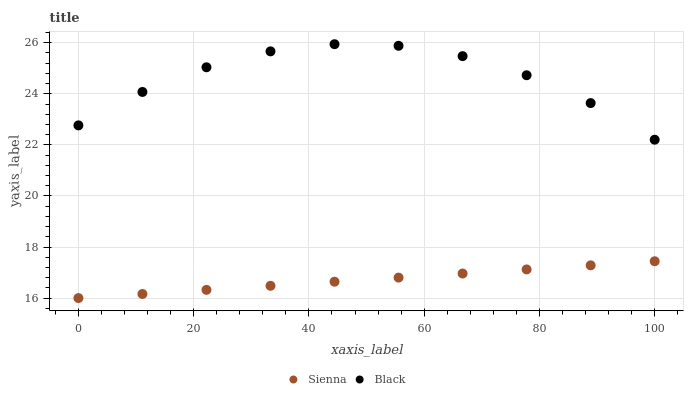Does Sienna have the minimum area under the curve?
Answer yes or no. Yes. Does Black have the maximum area under the curve?
Answer yes or no. Yes. Does Black have the minimum area under the curve?
Answer yes or no. No. Is Sienna the smoothest?
Answer yes or no. Yes. Is Black the roughest?
Answer yes or no. Yes. Is Black the smoothest?
Answer yes or no. No. Does Sienna have the lowest value?
Answer yes or no. Yes. Does Black have the lowest value?
Answer yes or no. No. Does Black have the highest value?
Answer yes or no. Yes. Is Sienna less than Black?
Answer yes or no. Yes. Is Black greater than Sienna?
Answer yes or no. Yes. Does Sienna intersect Black?
Answer yes or no. No. 